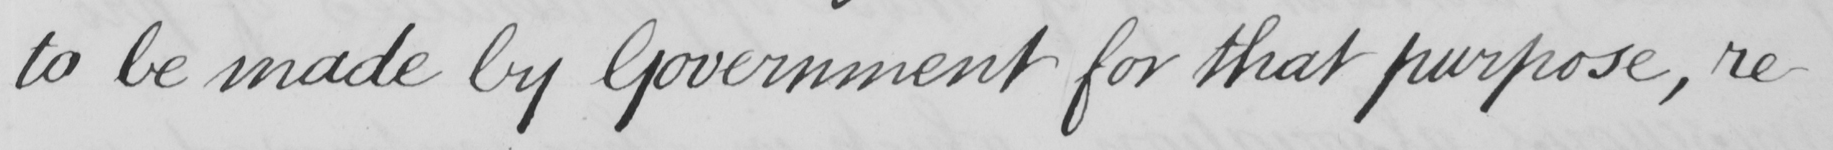What does this handwritten line say? to be made by Government for that purpose , re- 